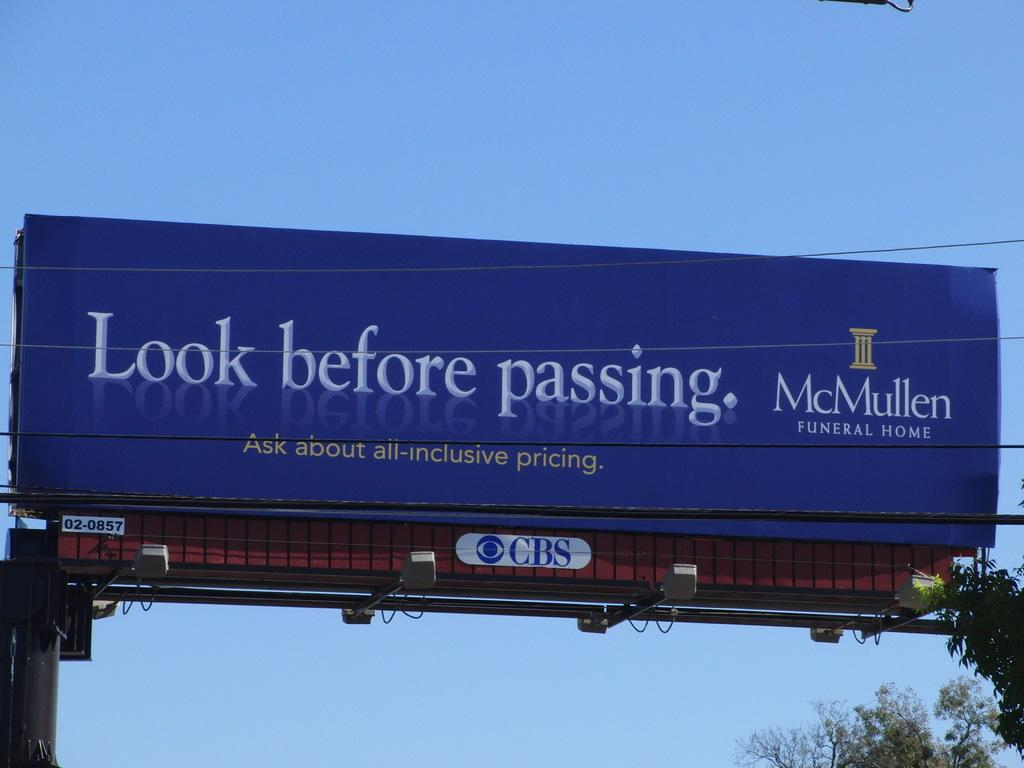<image>
Share a concise interpretation of the image provided. A funeral home advertises on a bill board. 